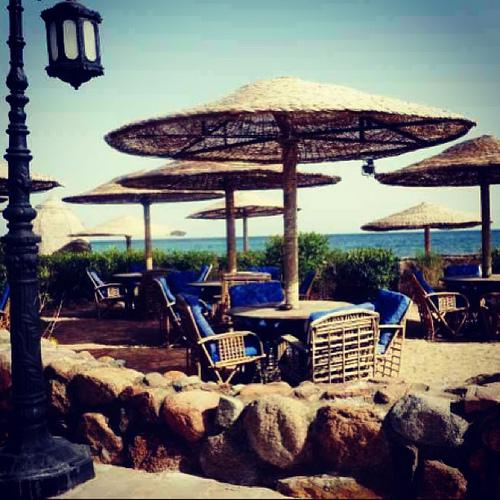Question: how many table umbrellas are visible?
Choices:
A. Nine.
B. Ten.
C. Eight.
D. Twelve.
Answer with the letter. Answer: C Question: what is in the horizon beyond the tables?
Choices:
A. Trees.
B. Body of water.
C. Cars.
D. Trucks.
Answer with the letter. Answer: B Question: where is this scene taking place?
Choices:
A. On a beach.
B. In the bedroom.
C. On the street.
D. In a clubhouse.
Answer with the letter. Answer: A Question: what are the umbrellas made of?
Choices:
A. Nylon.
B. Neoprene.
C. Fabric.
D. Straw.
Answer with the letter. Answer: D Question: what color are the umbrellas?
Choices:
A. Red.
B. Black.
C. Tan.
D. Blue.
Answer with the letter. Answer: C 